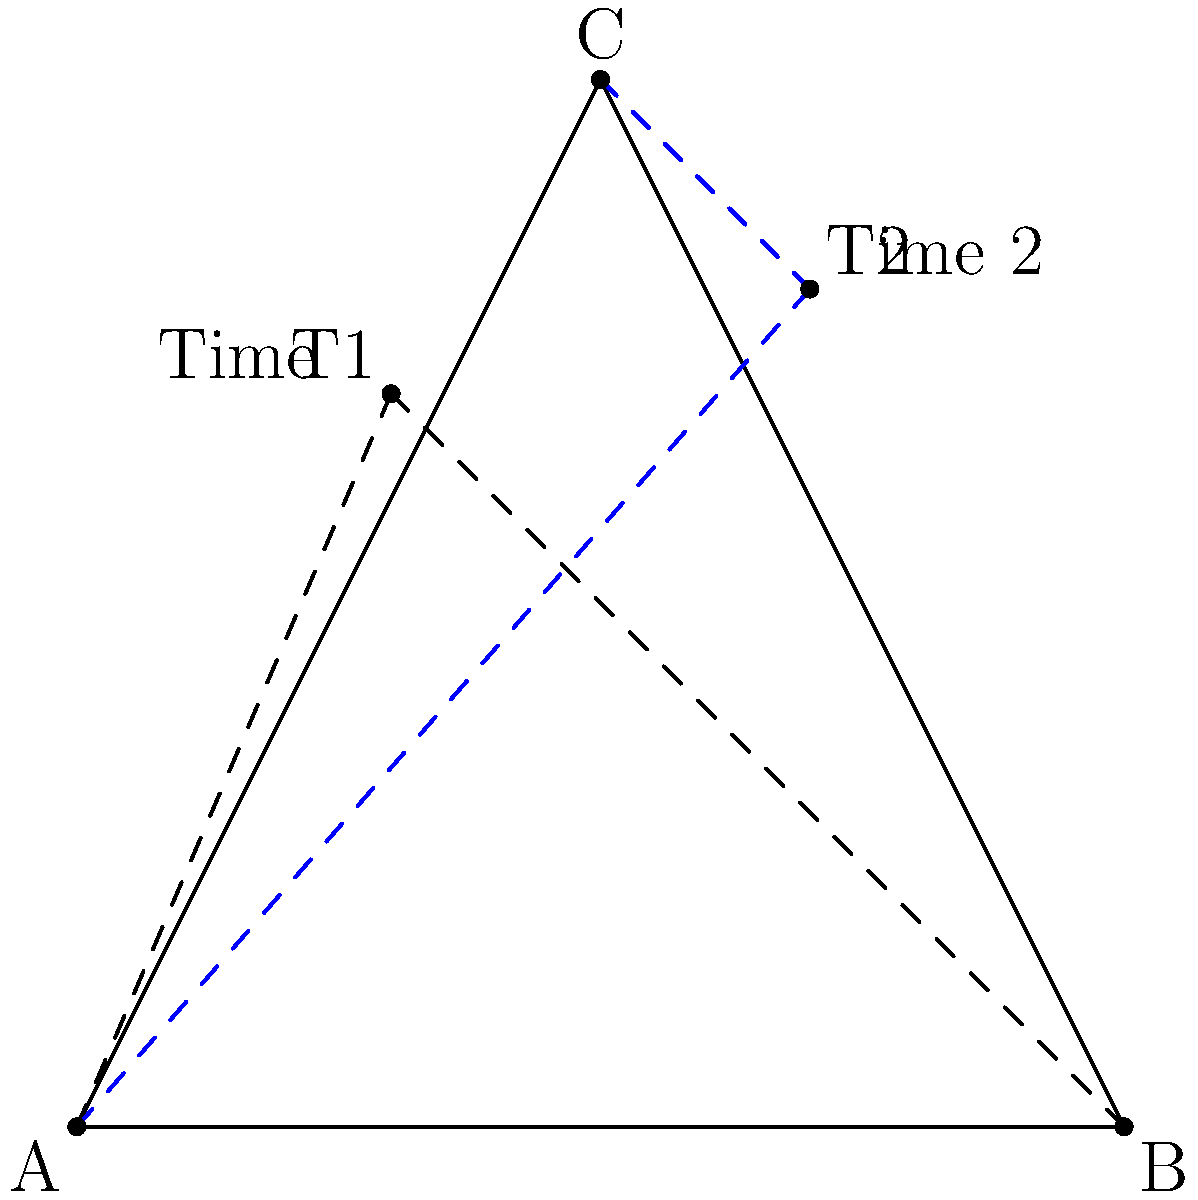From three vantage points A, B, and C, a moving target is observed at two different times. At Time 1, the target is spotted at the intersection of sight lines from A and B. At Time 2, it's seen at the intersection of sight lines from A and C. Given that the distance between A and B is 100 units, and the perpendicular distance from C to AB is 100 units, calculate the distance and direction the target moved between Time 1 and Time 2. To solve this problem, we'll follow these steps:

1) First, we need to determine the coordinates of all points. Let's set A as (0,0), B as (100,0), and C as (50,100).

2) We can find the coordinates of T1 (Time 1 position) by solving the equations of lines AB and AT1:
   Line AB: y = 0
   Line AT1: y = (70/30)x
   Solving these, we get T1 = (30,70)

3) Similarly, for T2 (Time 2 position), we solve lines AC and AT2:
   Line AC: y = 2x
   Line AT2: y = (80/70)x
   Solving these, we get T2 = (70,80)

4) Now we can calculate the distance between T1 and T2 using the distance formula:
   $$d = \sqrt{(x_2-x_1)^2 + (y_2-y_1)^2} = \sqrt{(70-30)^2 + (80-70)^2} = \sqrt{1600 + 100} = \sqrt{1700} \approx 41.23$$

5) For the direction, we can calculate the angle with respect to the positive x-axis:
   $$\theta = \tan^{-1}\left(\frac{y_2-y_1}{x_2-x_1}\right) = \tan^{-1}\left(\frac{80-70}{70-30}\right) = \tan^{-1}\left(\frac{10}{40}\right) \approx 14.04°$$

Therefore, the target moved approximately 41.23 units in a direction 14.04° above the positive x-axis.
Answer: 41.23 units, 14.04° above horizontal 